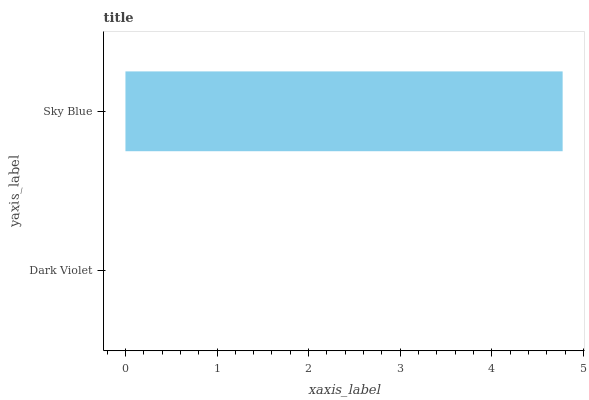Is Dark Violet the minimum?
Answer yes or no. Yes. Is Sky Blue the maximum?
Answer yes or no. Yes. Is Sky Blue the minimum?
Answer yes or no. No. Is Sky Blue greater than Dark Violet?
Answer yes or no. Yes. Is Dark Violet less than Sky Blue?
Answer yes or no. Yes. Is Dark Violet greater than Sky Blue?
Answer yes or no. No. Is Sky Blue less than Dark Violet?
Answer yes or no. No. Is Sky Blue the high median?
Answer yes or no. Yes. Is Dark Violet the low median?
Answer yes or no. Yes. Is Dark Violet the high median?
Answer yes or no. No. Is Sky Blue the low median?
Answer yes or no. No. 